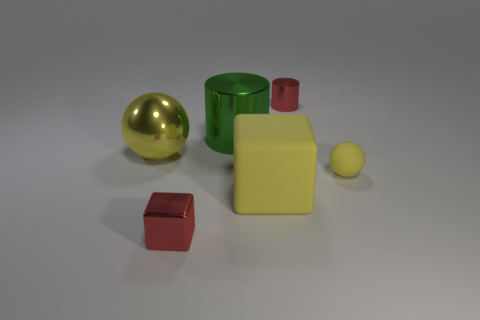What color is the small sphere in front of the red metal object right of the red metal object that is on the left side of the yellow block?
Offer a very short reply. Yellow. What number of yellow metallic spheres have the same size as the shiny block?
Make the answer very short. 0. There is a cylinder behind the green cylinder; what is its color?
Ensure brevity in your answer.  Red. How many other objects are the same size as the yellow shiny sphere?
Offer a terse response. 2. There is a thing that is behind the small yellow object and right of the big cylinder; what is its size?
Give a very brief answer. Small. Does the big matte block have the same color as the tiny thing that is to the right of the tiny cylinder?
Offer a terse response. Yes. Is there another yellow metal thing that has the same shape as the tiny yellow object?
Give a very brief answer. Yes. What number of objects are either large rubber things or yellow rubber blocks in front of the small yellow ball?
Ensure brevity in your answer.  1. How many other objects are the same material as the large block?
Offer a terse response. 1. How many things are matte blocks or blue matte things?
Ensure brevity in your answer.  1. 